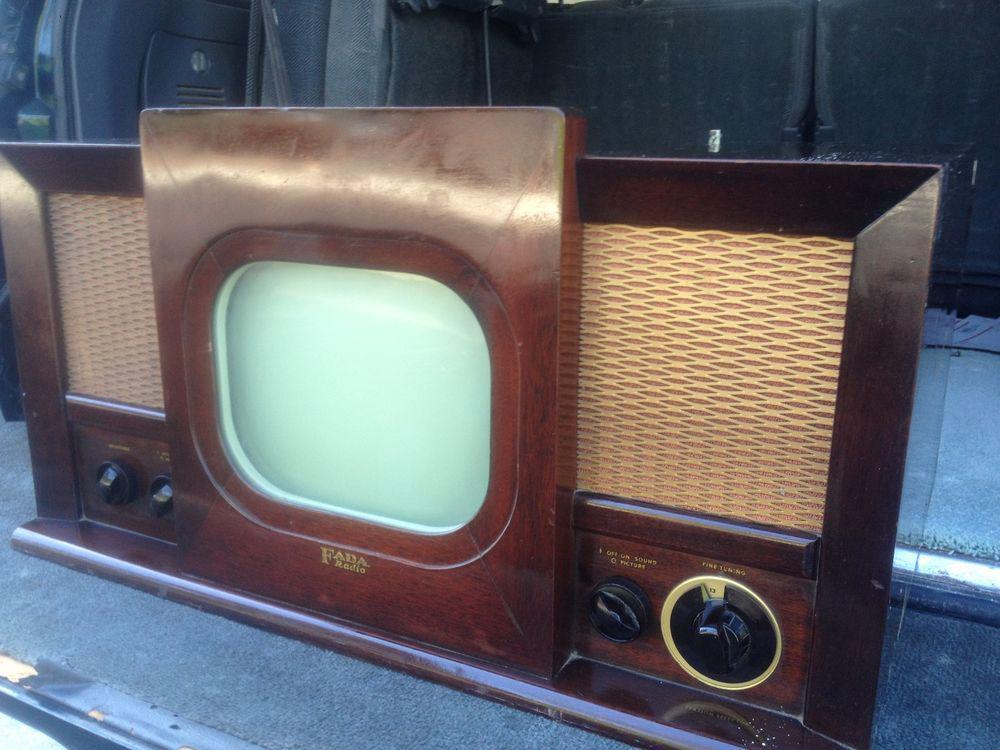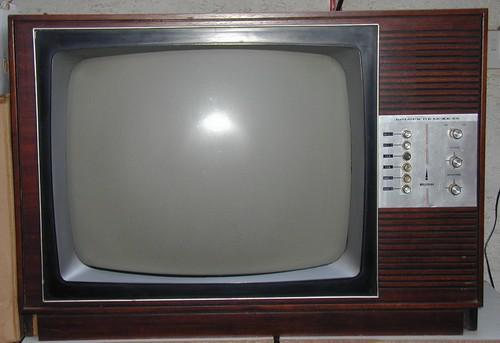The first image is the image on the left, the second image is the image on the right. Examine the images to the left and right. Is the description "Two old televisions have brown cases." accurate? Answer yes or no. Yes. The first image is the image on the left, the second image is the image on the right. For the images displayed, is the sentence "the controls are right of the screen in the image on the right" factually correct? Answer yes or no. Yes. 